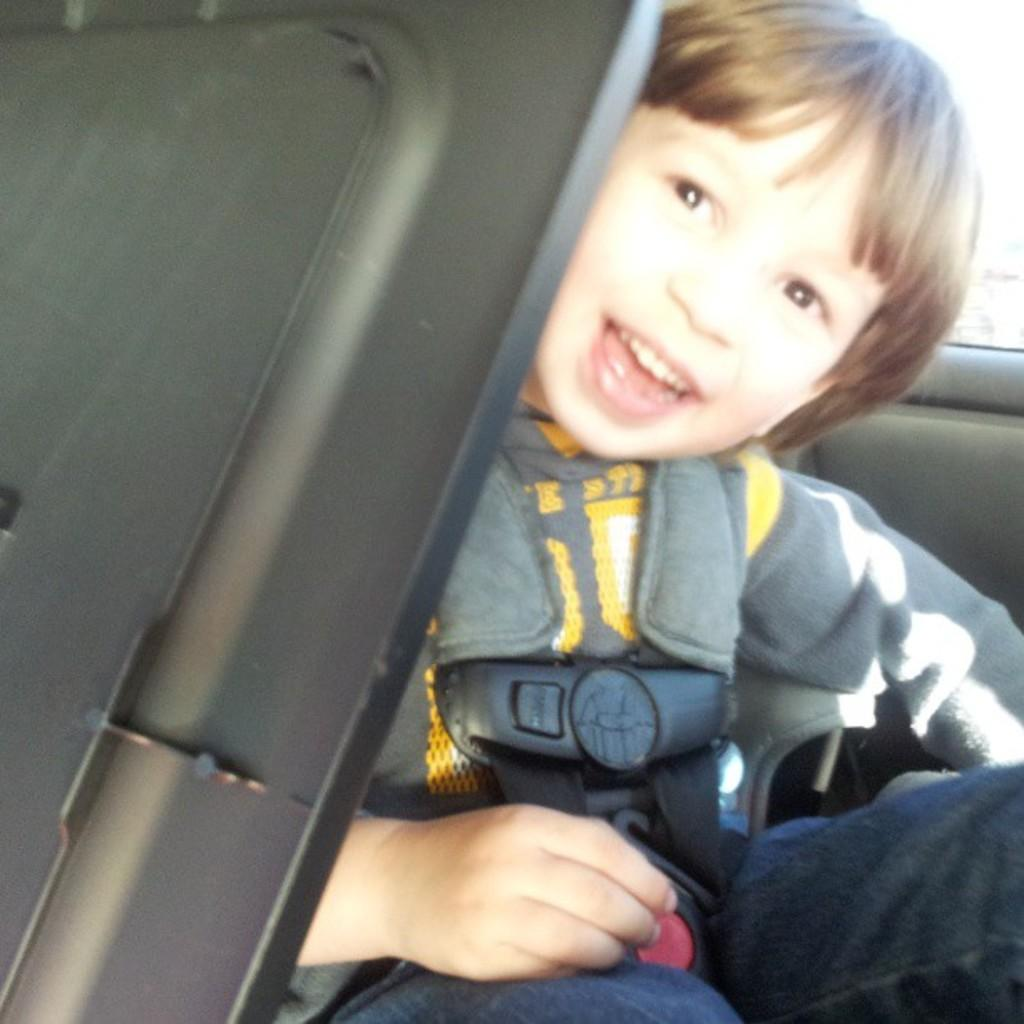What is the main subject in the center of the image? There is a car in the center of the image. Is there anyone inside the car? Yes, there is a boy sitting in the car. How does the boy appear to feel in the image? The boy is smiling, as indicated by the expression on his face. How many chickens are running around the car in the image? There are no chickens present in the image; it only features a car and a boy. 